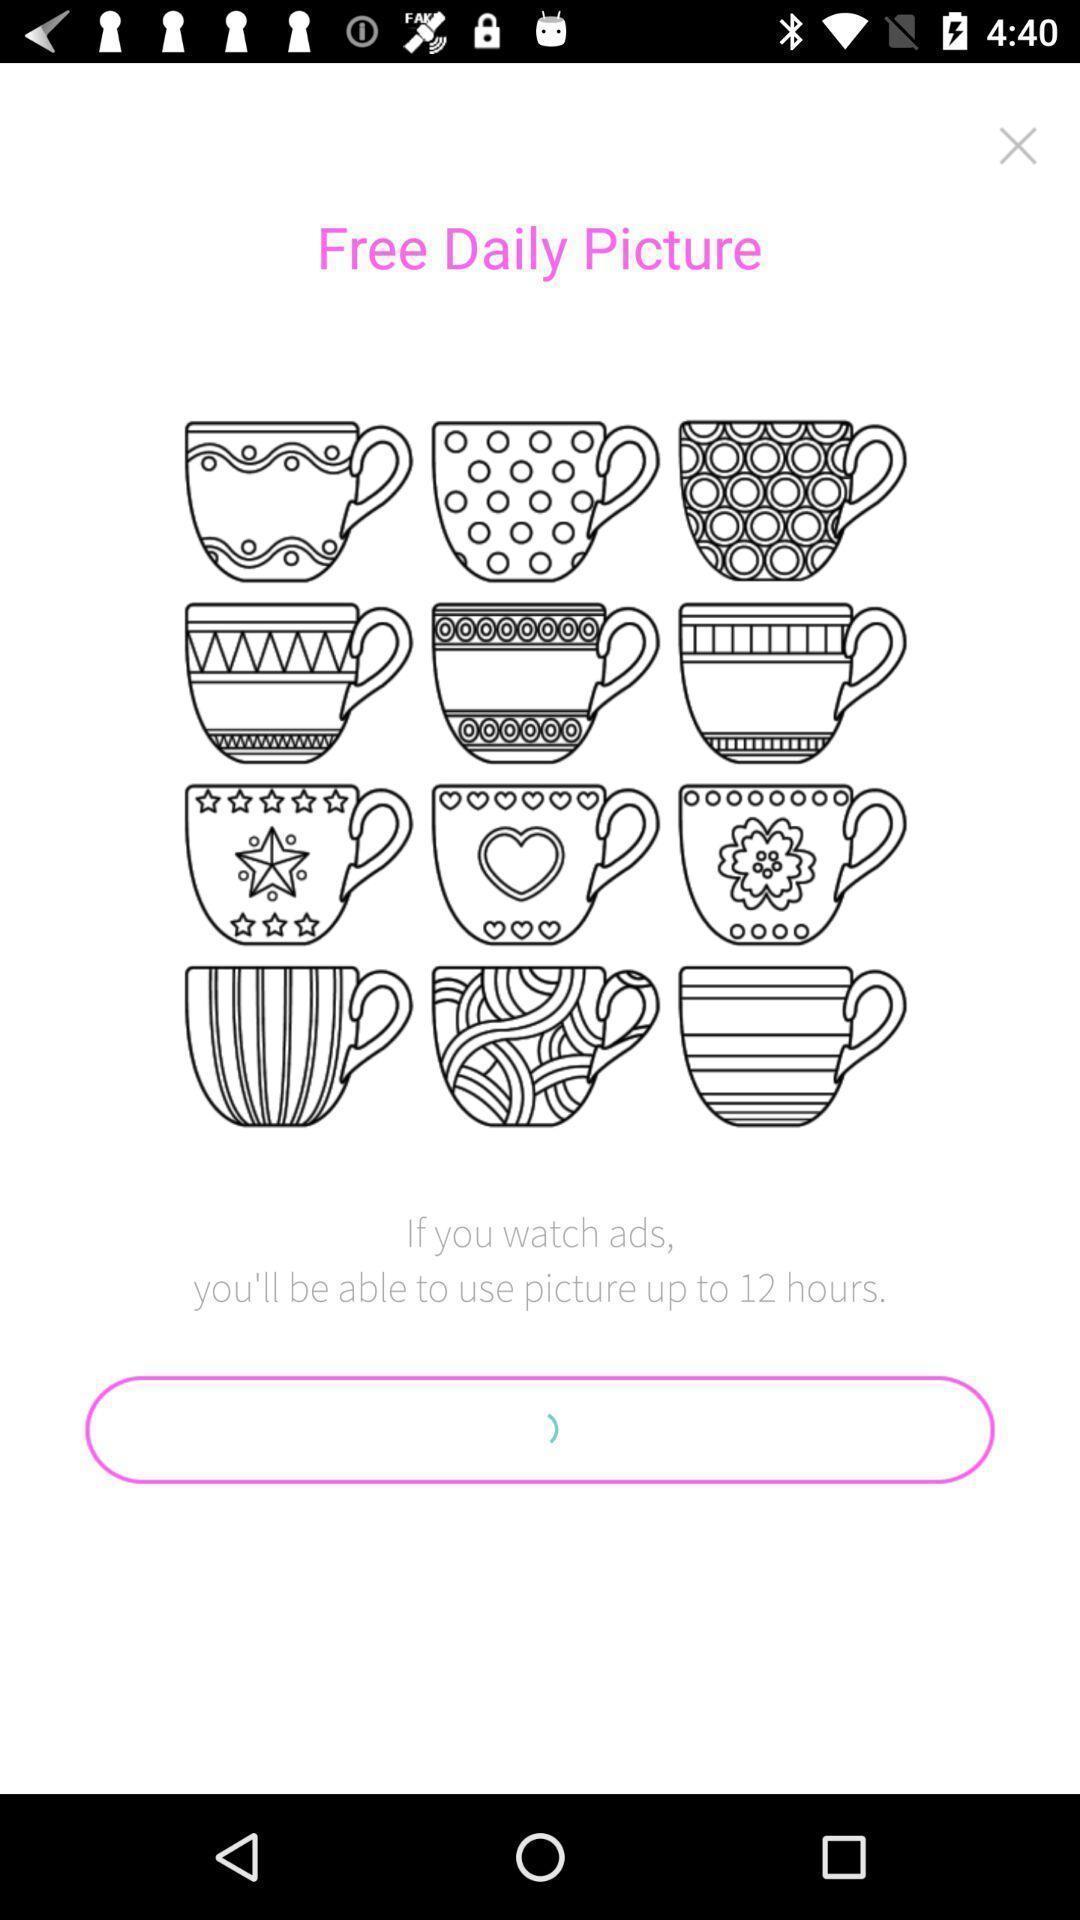Provide a textual representation of this image. Welcome page for the photo drawing app. 